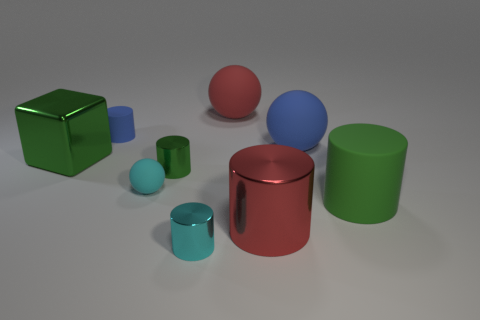What number of gray objects are metallic blocks or metal things?
Ensure brevity in your answer.  0. Are there any blue objects of the same size as the cyan metal cylinder?
Your answer should be compact. Yes. What is the material of the green cube that is the same size as the red sphere?
Offer a very short reply. Metal. There is a red object that is in front of the green matte cylinder; is its size the same as the thing left of the blue rubber cylinder?
Offer a very short reply. Yes. How many things are large balls or large metal things behind the small green cylinder?
Offer a very short reply. 3. Are there any small brown metal things that have the same shape as the red matte object?
Ensure brevity in your answer.  No. What is the size of the red thing in front of the large matte ball that is in front of the tiny blue rubber cylinder?
Keep it short and to the point. Large. Is the color of the tiny rubber ball the same as the tiny matte cylinder?
Offer a very short reply. No. How many metallic objects are either blue cubes or large blue spheres?
Your answer should be compact. 0. What number of tiny cylinders are there?
Ensure brevity in your answer.  3. 